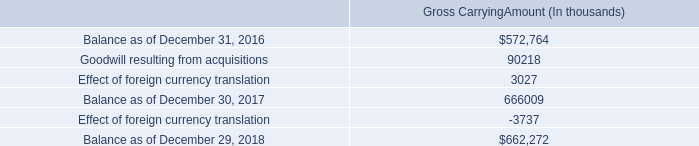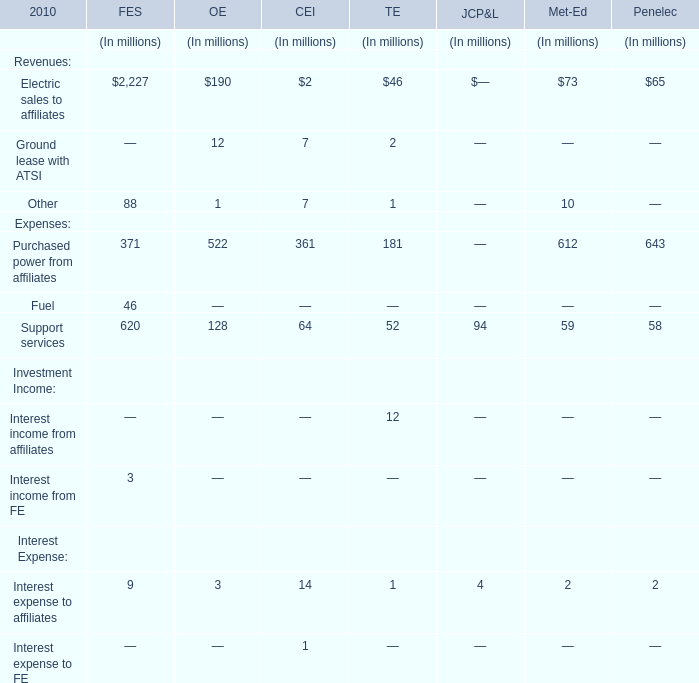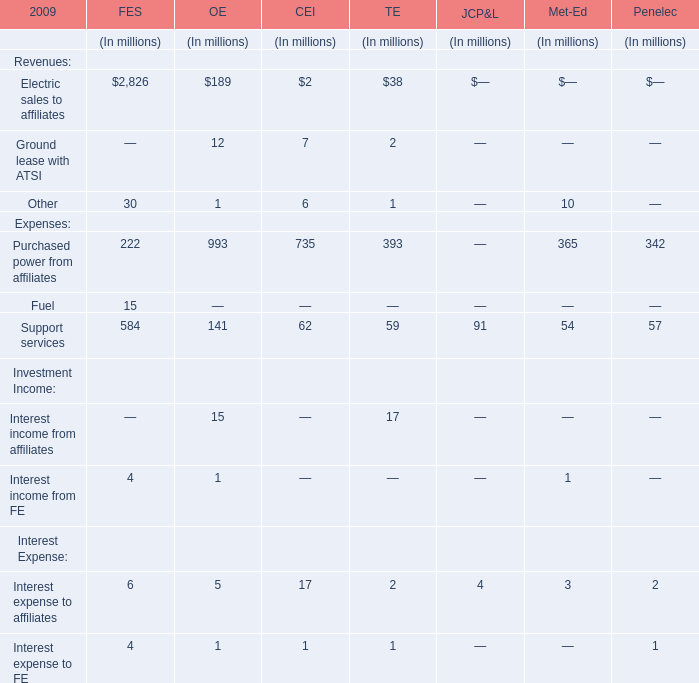What's the sum of all Revenues of TE that are greater than 40 in 2010? (in dollars in millions) 
Answer: 46. 